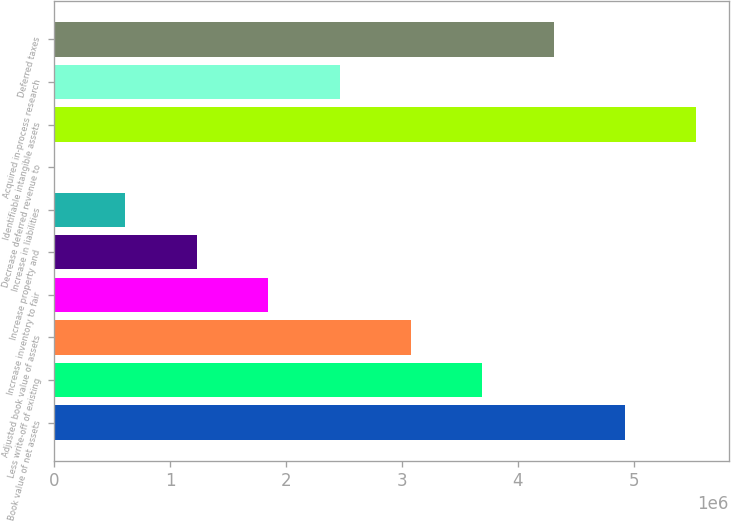Convert chart to OTSL. <chart><loc_0><loc_0><loc_500><loc_500><bar_chart><fcel>Book value of net assets<fcel>Less write-off of existing<fcel>Adjusted book value of assets<fcel>Increase inventory to fair<fcel>Increase property and<fcel>Increase in liabilities<fcel>Decrease deferred revenue to<fcel>Identifiable intangible assets<fcel>Acquired in-process research<fcel>Deferred taxes<nl><fcel>4.9256e+06<fcel>3.6943e+06<fcel>3.07865e+06<fcel>1.84735e+06<fcel>1.2317e+06<fcel>616050<fcel>400<fcel>5.54125e+06<fcel>2.463e+06<fcel>4.30995e+06<nl></chart> 